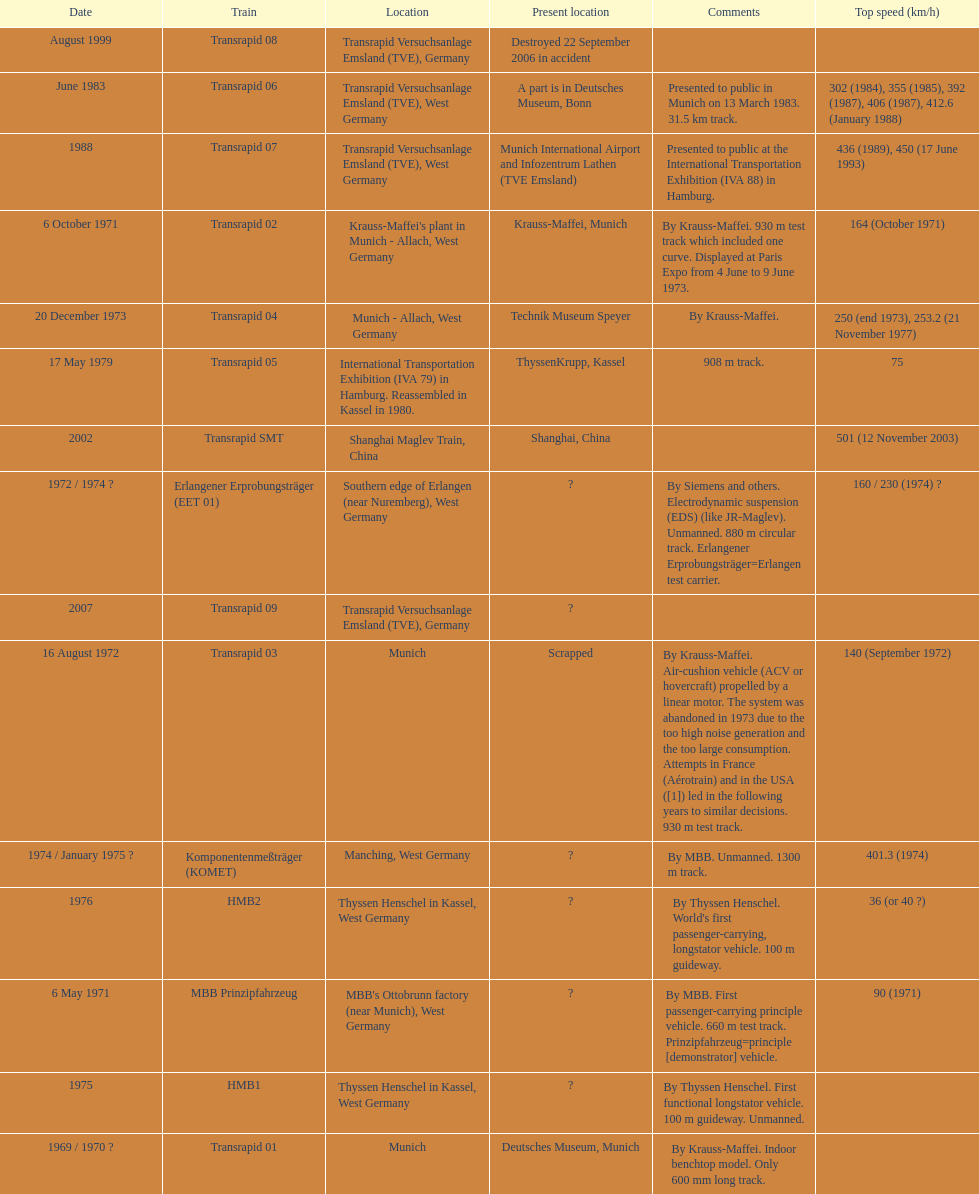What train was developed after the erlangener erprobungstrager? Transrapid 04. 